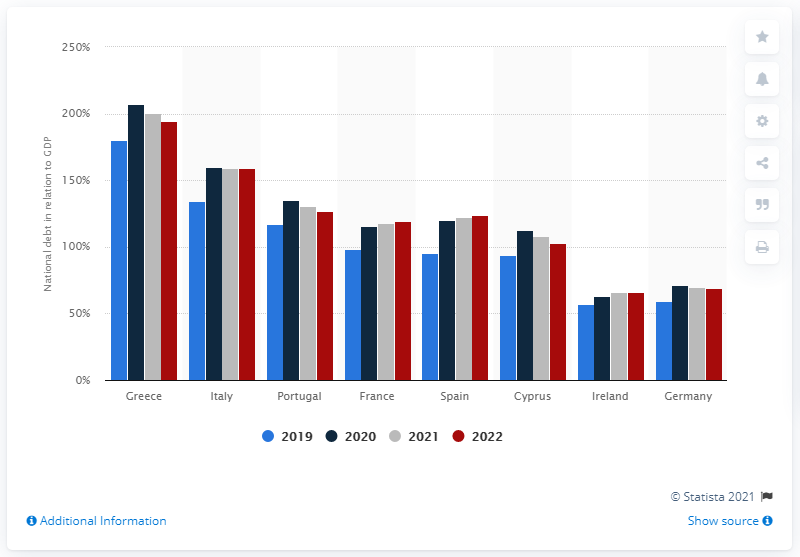Highlight a few significant elements in this photo. It is estimated that Greece's national debt will account for approximately 194.8% of the country's GDP in 2022. 